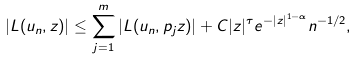Convert formula to latex. <formula><loc_0><loc_0><loc_500><loc_500>\left | L ( u _ { n } , z ) \right | \leq \sum _ { j = 1 } ^ { m } \left | L ( u _ { n } , p _ { j } z ) \right | + C | z | ^ { \tau } e ^ { - | z | ^ { 1 - \alpha } } n ^ { - 1 / 2 } ,</formula> 